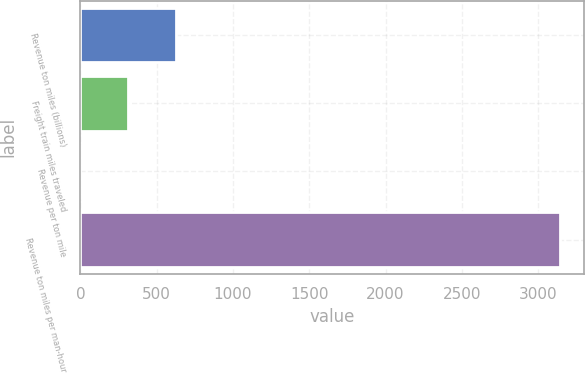Convert chart to OTSL. <chart><loc_0><loc_0><loc_500><loc_500><bar_chart><fcel>Revenue ton miles (billions)<fcel>Freight train miles traveled<fcel>Revenue per ton mile<fcel>Revenue ton miles per man-hour<nl><fcel>629.24<fcel>314.64<fcel>0.04<fcel>3146<nl></chart> 